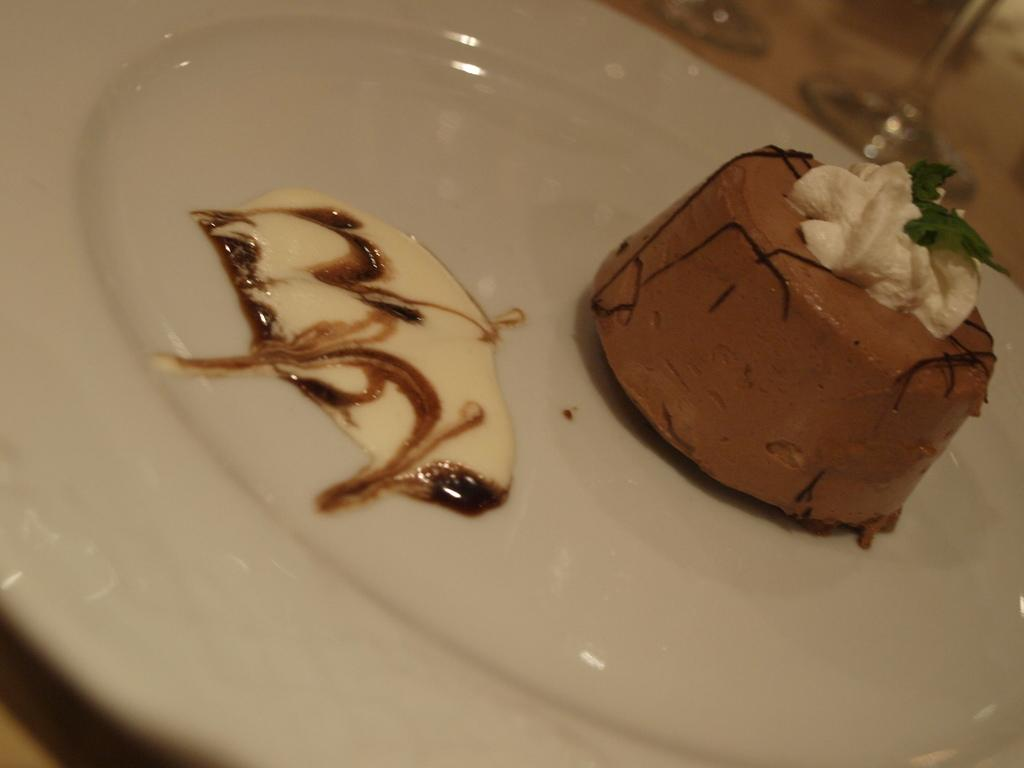What is on the plate that is visible in the image? There are food items on the plate in the image. What color is the plate? The plate is white. What objects are behind the plate that resemble glasses? There are objects behind the plate that resemble glasses. What type of engine is powering the food on the plate? There is no engine present in the image, and the food is not being powered by any engine. 